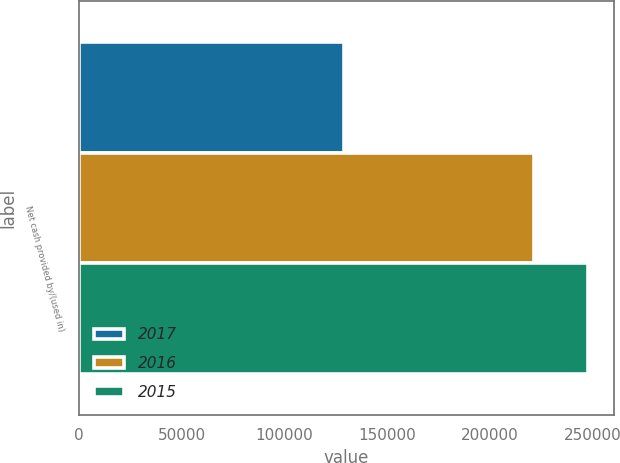Convert chart. <chart><loc_0><loc_0><loc_500><loc_500><stacked_bar_chart><ecel><fcel>Net cash provided by/(used in)<nl><fcel>2017<fcel>128846<nl><fcel>2016<fcel>221483<nl><fcel>2015<fcel>247747<nl></chart> 